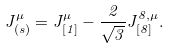<formula> <loc_0><loc_0><loc_500><loc_500>J ^ { \mu } _ { ( s ) } = J ^ { \mu } _ { [ 1 ] } - \frac { 2 } { \sqrt { 3 } } J ^ { 8 , \mu } _ { [ 8 ] } .</formula> 